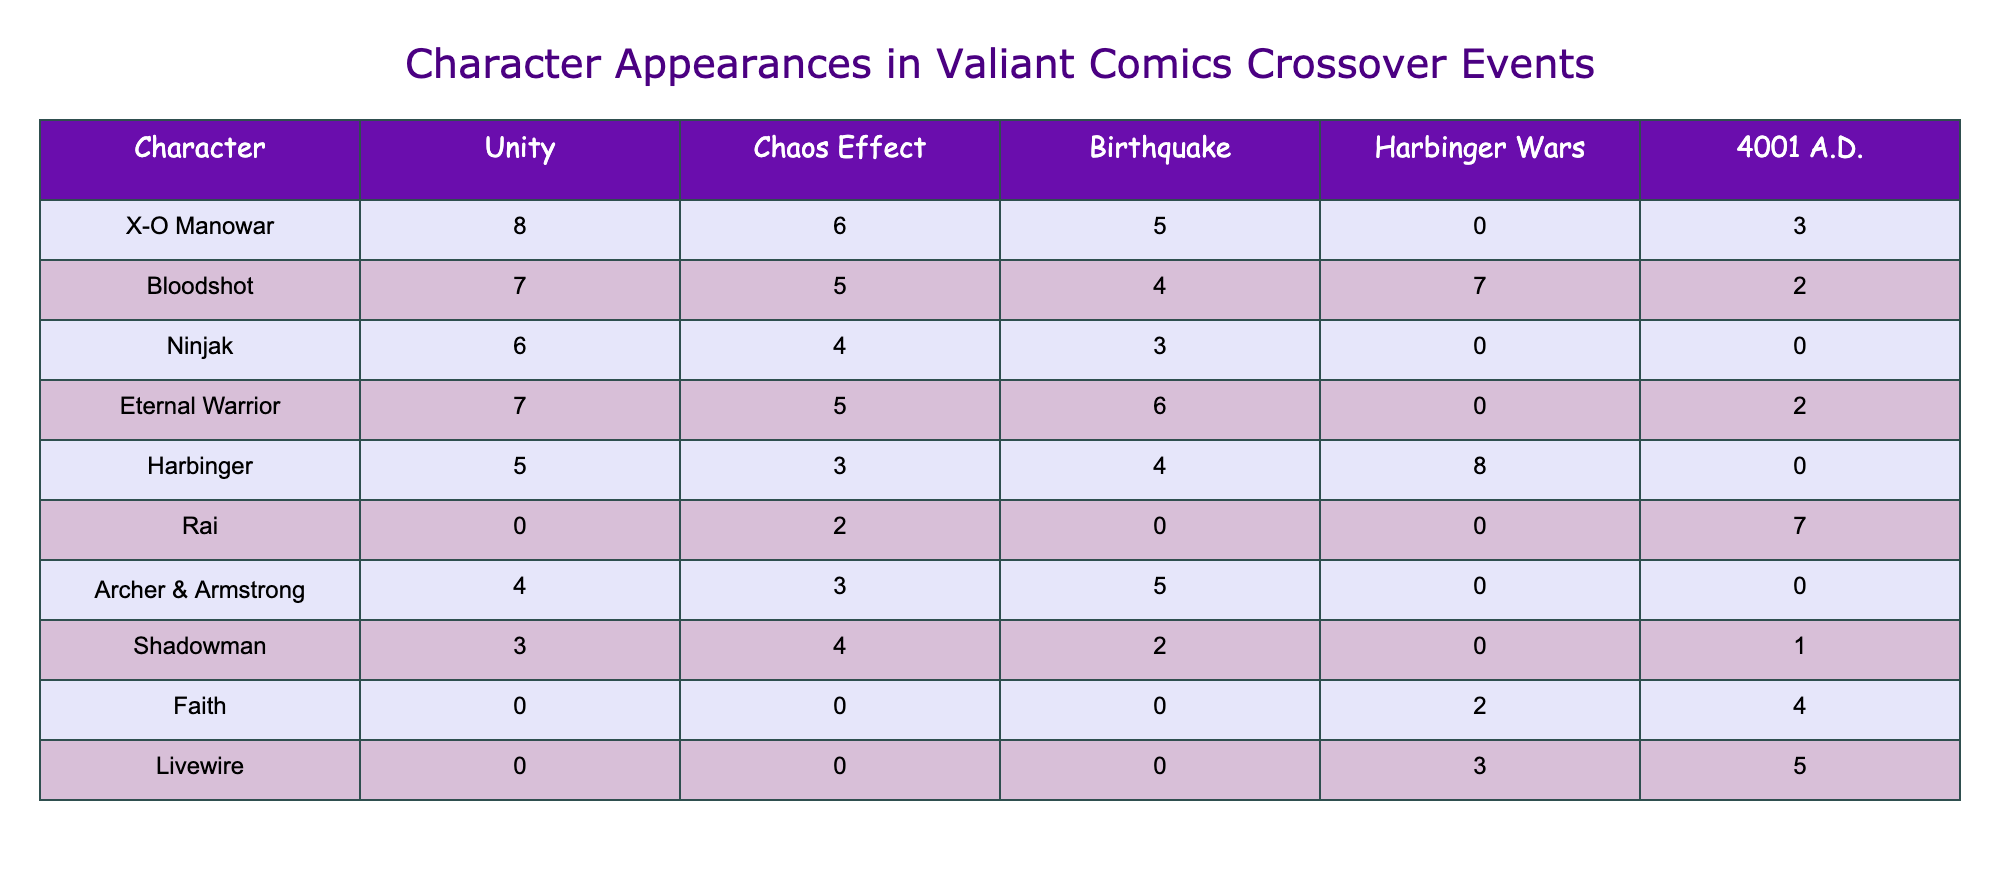What character appears the most in the Unity crossover event? Looking at the Unity column, X-O Manowar appears 8 times, which is more than any other character listed.
Answer: X-O Manowar How many appearances does Bloodshot have across all crossover events? Summing Bloodshot's appearances from all event columns: 7 (Unity) + 5 (Chaos Effect) + 4 (Birthquake) + 7 (Harbinger Wars) + 2 (4001 A.D.) = 25.
Answer: 25 Is Rai featured in the Harbinger Wars event? Rai has 0 appearances listed for the Harbinger Wars event.
Answer: No Which character has the least appearances in the Chaos Effect event? By reviewing the numbers in the Chaos Effect column, Ninjak has the least appearances with a count of 4.
Answer: Ninjak What is the total number of appearances for Eternal Warrior across all crossover events? Eternal Warrior's appearances are 7 (Unity) + 5 (Chaos Effect) + 6 (Birthquake) + 0 (Harbinger Wars) + 2 (4001 A.D.), resulting in a total of 20 appearances.
Answer: 20 Does Faith appear in the Unity crossover event? Faith has 0 appearances listed in the Unity column.
Answer: No Which character has the highest combined appearances in Chaos Effect and Birthquake events? Adding the appearances for Chaos Effect and Birthquake: X-O Manowar (6+5=11), Bloodshot (5+4=9), Eternal Warrior (5+6=11), Harbinger (3+4=7), Rai (2+0=2), Archer & Armstrong (3+5=8), Shadowman (4+2=6), Faith (0+0=0), Livewire (0+0=0). The highest combined appearances are 11 for X-O Manowar and Eternal Warrior.
Answer: X-O Manowar and Eternal Warrior What percentage of Shadowman’s total appearances are from the Chaos Effect event? Shadowman has a total of 10 appearances (3 in Unity + 4 in Chaos Effect + 2 in Birthquake + 0 in Harbinger Wars + 1 in 4001 A.D.). The appearances in Chaos Effect (4) are calculated as (4/10) * 100 = 40%.
Answer: 40% 